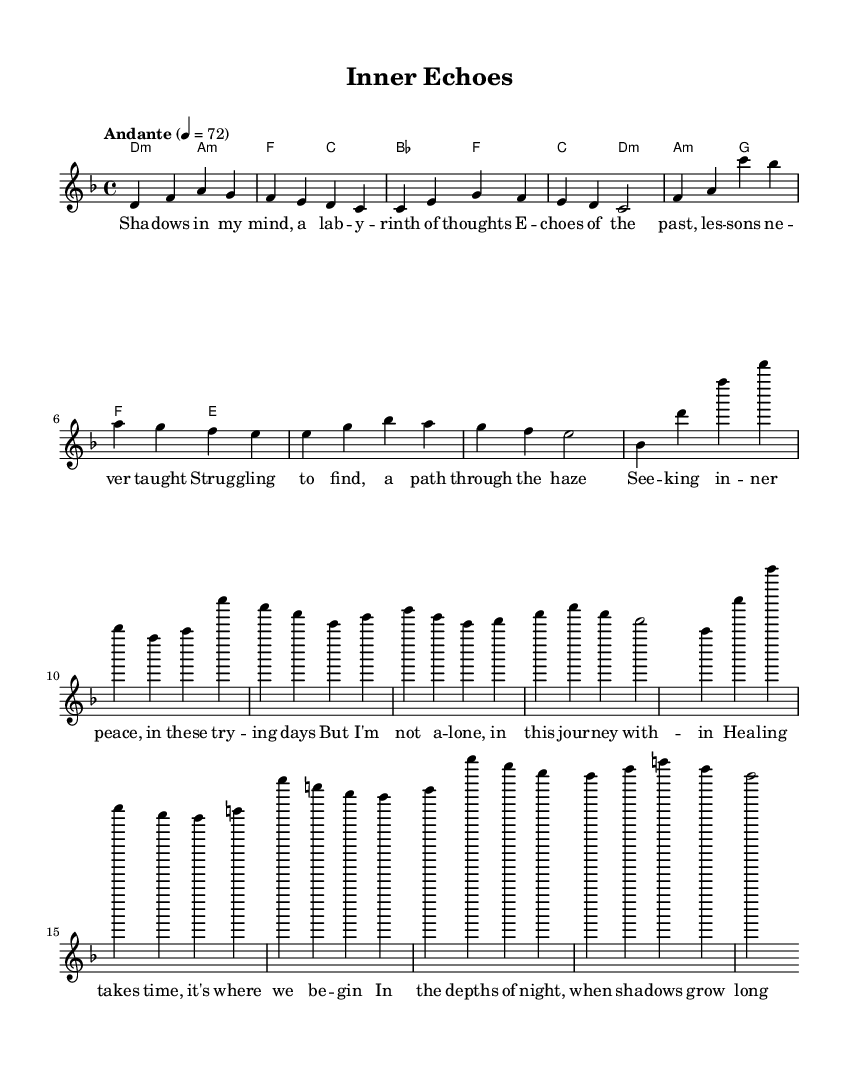What is the key signature of this piece? The key signature is indicated at the beginning of the staff and shows two flats, which corresponds to the key of D minor.
Answer: D minor What is the time signature of this piece? The time signature is found right after the key signature, represented as 4/4, meaning there are four beats per measure.
Answer: 4/4 What is the tempo marking for this piece? The tempo marking is written as "Andante" at the start of the score, which suggests a moderate pace. The numerical marking can also be seen, indicating 72 beats per minute.
Answer: Andante How many bars are in the verse section? The verse section consists of eight bars, as inferred from the melody notation provided above the lyrics, counting each segment divided by the vertical lines.
Answer: 8 What is the initial chord of the verses? By looking at the chord symbols above the verse melody, the first chord is indicated as a D minor chord.
Answer: D minor What feelings are suggested by the lyrics in the bridge? The bridge lyrics focus on themes of resilience and strength in difficult times, reflecting a journey through struggles and suggesting hope.
Answer: Resilience What musical structure is used in this piece? The piece follows a standard structure of verse-chorus-bridge, commonly found in rock ballads, as indicated by the repetition and arrangement of sections.
Answer: Verse-chorus-bridge 